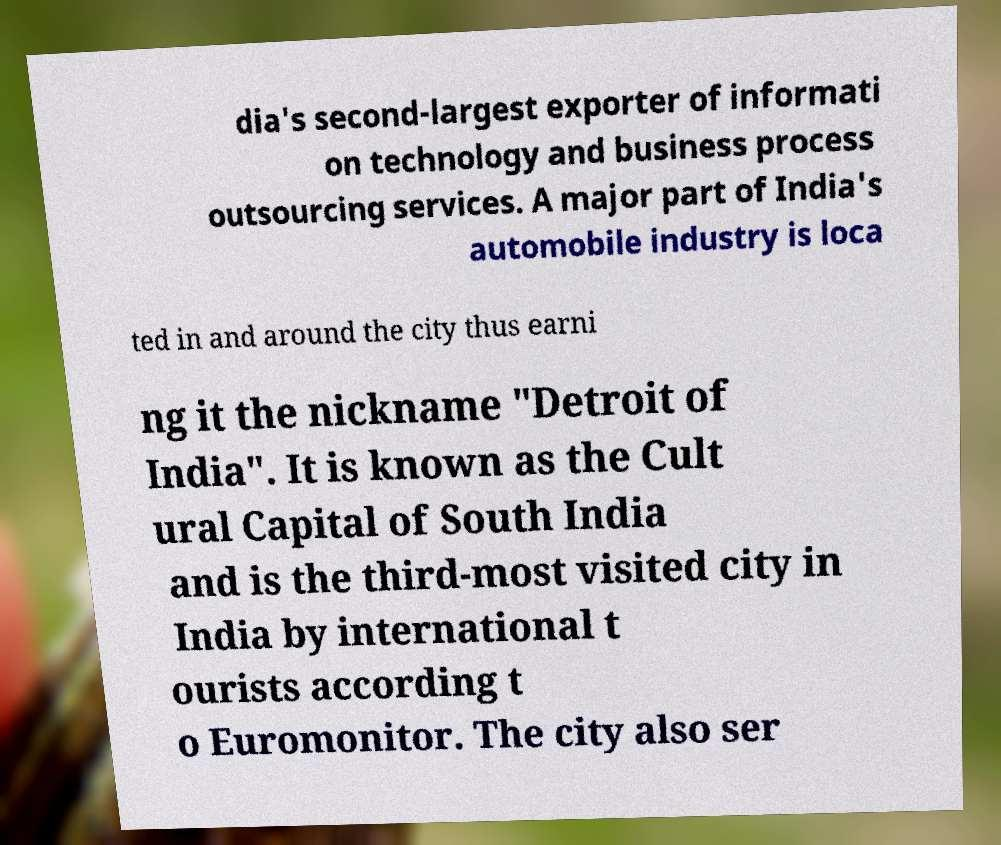Could you assist in decoding the text presented in this image and type it out clearly? dia's second-largest exporter of informati on technology and business process outsourcing services. A major part of India's automobile industry is loca ted in and around the city thus earni ng it the nickname "Detroit of India". It is known as the Cult ural Capital of South India and is the third-most visited city in India by international t ourists according t o Euromonitor. The city also ser 